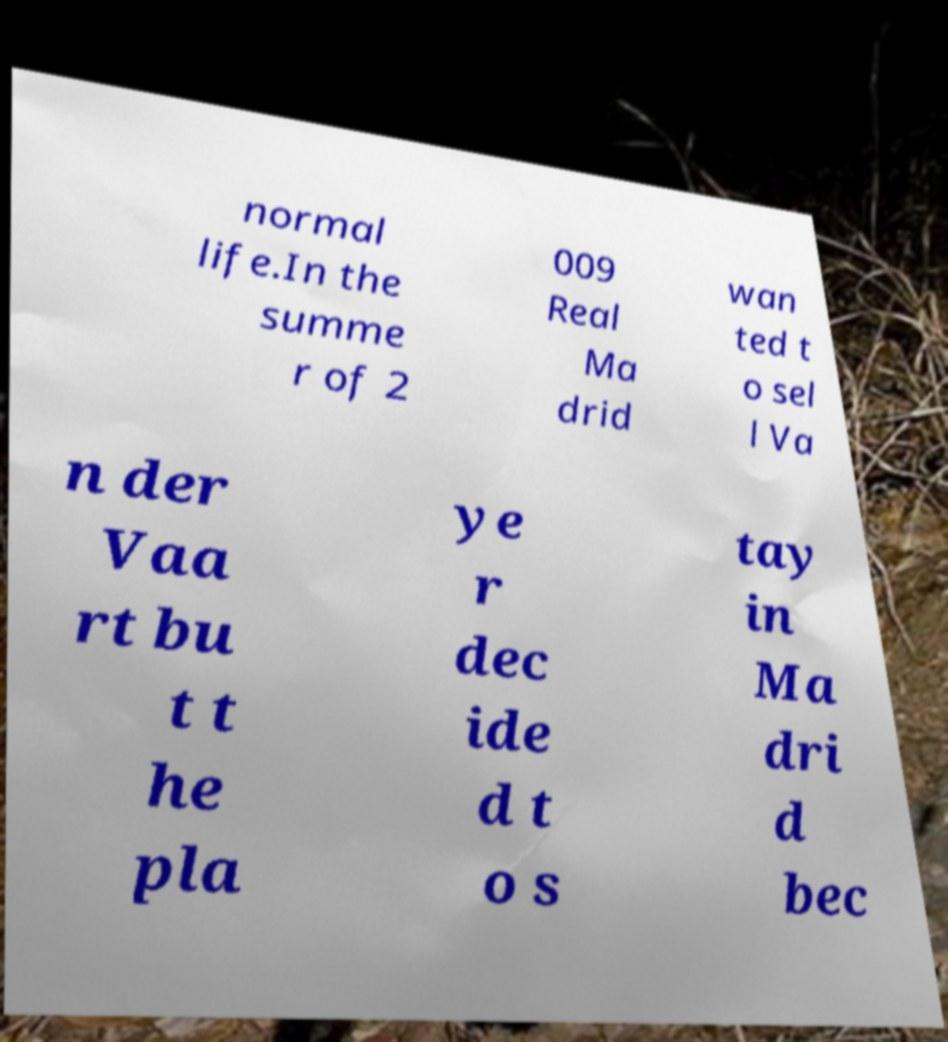Could you assist in decoding the text presented in this image and type it out clearly? normal life.In the summe r of 2 009 Real Ma drid wan ted t o sel l Va n der Vaa rt bu t t he pla ye r dec ide d t o s tay in Ma dri d bec 